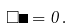<formula> <loc_0><loc_0><loc_500><loc_500>\Box \Phi = 0 \, .</formula> 